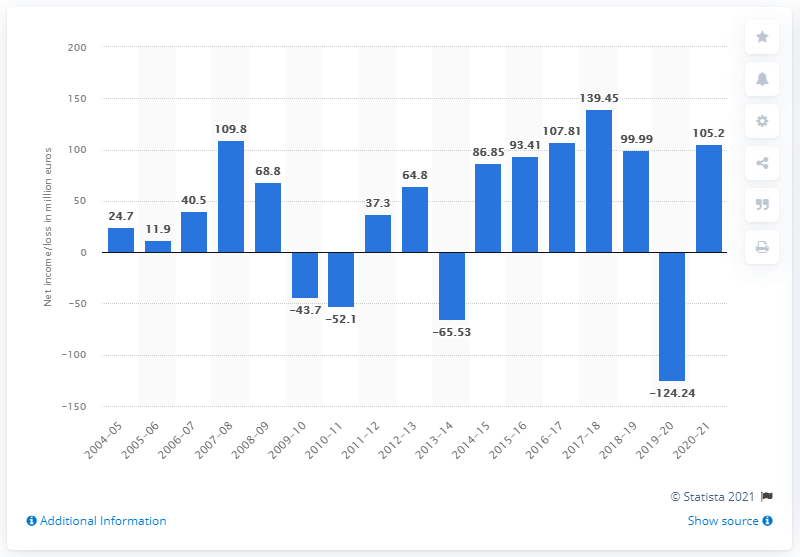Mention a couple of crucial points in this snapshot. In the financial year 2020-21, Ubisoft's net income was 105.2 million. 